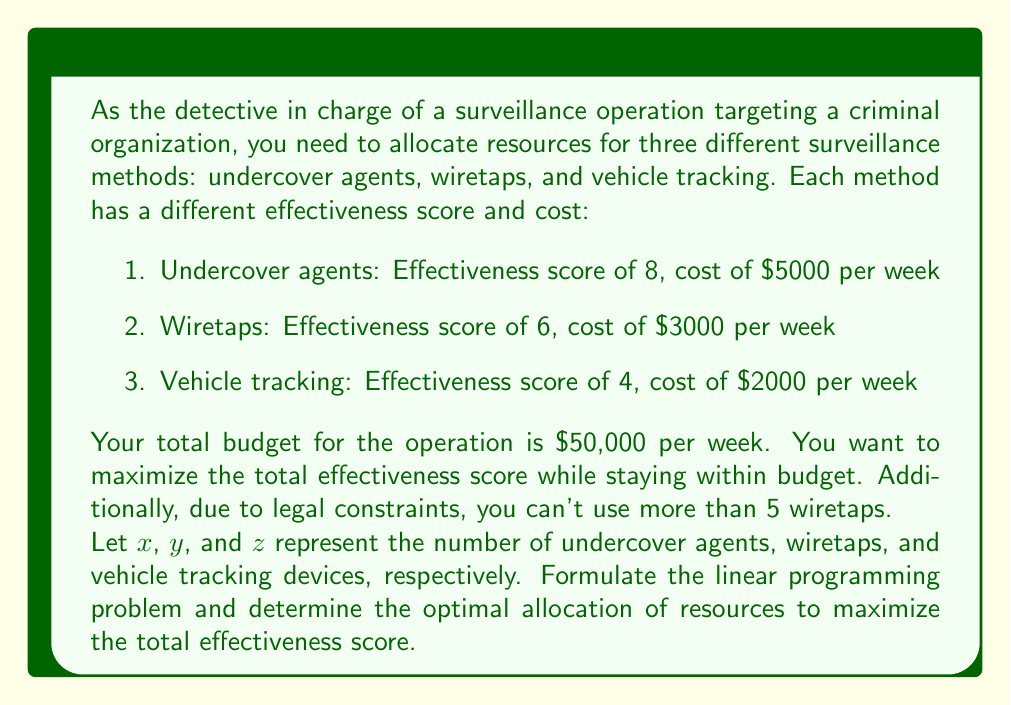Solve this math problem. To solve this problem, we need to formulate a linear programming model and then solve it. Let's go through this step-by-step:

1. Define the objective function:
   We want to maximize the total effectiveness score, which is:
   $$8x + 6y + 4z$$

2. Identify the constraints:
   a) Budget constraint: $5000x + 3000y + 2000z \leq 50000$
   b) Wiretap constraint: $y \leq 5$
   c) Non-negativity constraints: $x \geq 0$, $y \geq 0$, $z \geq 0$

3. The complete linear programming model:
   Maximize: $8x + 6y + 4z$
   Subject to:
   $$5000x + 3000y + 2000z \leq 50000$$
   $$y \leq 5$$
   $$x, y, z \geq 0$$

4. To solve this, we can use the simplex method or a linear programming solver. However, we can also reason through this problem:

   a) Since undercover agents have the highest effectiveness score per dollar spent (8/5000 = 0.0016), we should allocate as much budget as possible to them.
   
   b) Wiretaps have the second-highest effectiveness score per dollar (6/3000 = 0.002), so we should use the maximum allowed, which is 5.
   
   c) After allocating resources to 5 wiretaps, we can calculate the remaining budget:
      $50000 - (5 * 3000) = 35000$
   
   d) We can now allocate the remaining budget to undercover agents:
      Number of undercover agents = $35000 / 5000 = 7$

   e) There's no budget left for vehicle tracking devices.

5. The optimal solution is:
   x (undercover agents) = 7
   y (wiretaps) = 5
   z (vehicle tracking devices) = 0

6. The maximum total effectiveness score is:
   $8(7) + 6(5) + 4(0) = 56 + 30 + 0 = 86$
Answer: 7 undercover agents, 5 wiretaps, 0 vehicle tracking devices; Total effectiveness score: 86 